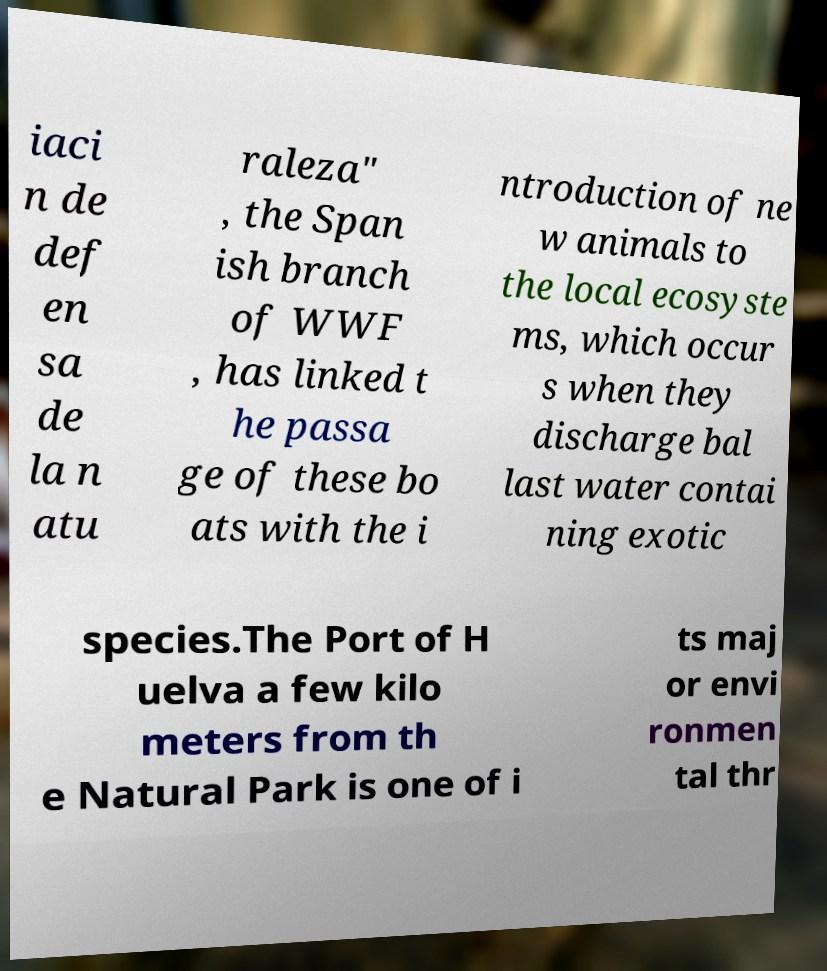Please read and relay the text visible in this image. What does it say? iaci n de def en sa de la n atu raleza" , the Span ish branch of WWF , has linked t he passa ge of these bo ats with the i ntroduction of ne w animals to the local ecosyste ms, which occur s when they discharge bal last water contai ning exotic species.The Port of H uelva a few kilo meters from th e Natural Park is one of i ts maj or envi ronmen tal thr 